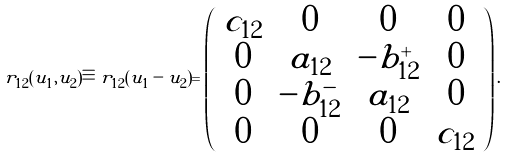<formula> <loc_0><loc_0><loc_500><loc_500>r _ { 1 2 } ( u _ { 1 } , u _ { 2 } ) \equiv r _ { 1 2 } ( u _ { 1 } - u _ { 2 } ) = \left ( \begin{array} { c c c c } c _ { 1 2 } & 0 & 0 & 0 \\ 0 & a _ { 1 2 } & - b ^ { + } _ { 1 2 } & 0 \\ 0 & - b ^ { - } _ { 1 2 } & a _ { 1 2 } & 0 \\ 0 & 0 & 0 & c _ { 1 2 } \end{array} \right ) .</formula> 